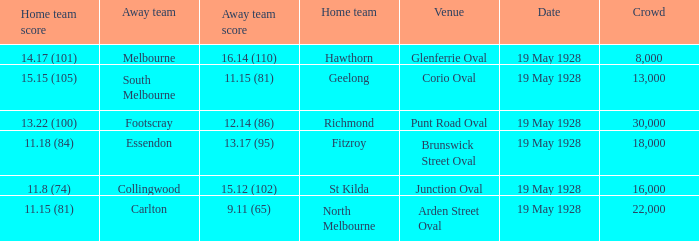What was the listed crowd at junction oval? 16000.0. 